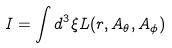Convert formula to latex. <formula><loc_0><loc_0><loc_500><loc_500>I = \int d ^ { 3 } \xi L ( r , A _ { \theta } , A _ { \phi } )</formula> 